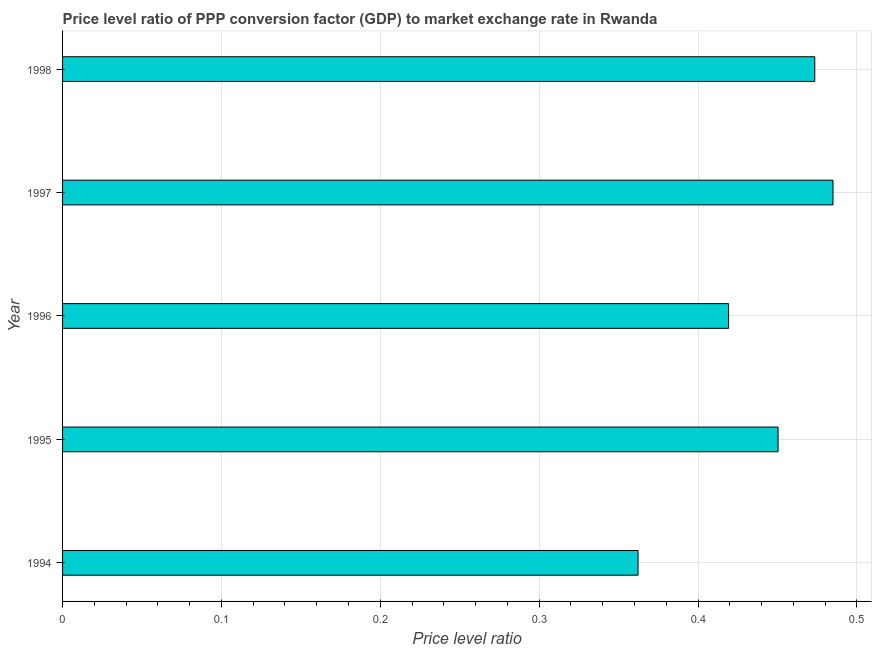What is the title of the graph?
Ensure brevity in your answer.  Price level ratio of PPP conversion factor (GDP) to market exchange rate in Rwanda. What is the label or title of the X-axis?
Provide a succinct answer. Price level ratio. What is the price level ratio in 1995?
Offer a terse response. 0.45. Across all years, what is the maximum price level ratio?
Offer a very short reply. 0.48. Across all years, what is the minimum price level ratio?
Provide a succinct answer. 0.36. In which year was the price level ratio maximum?
Your response must be concise. 1997. What is the sum of the price level ratio?
Offer a terse response. 2.19. What is the difference between the price level ratio in 1995 and 1998?
Your answer should be very brief. -0.02. What is the average price level ratio per year?
Make the answer very short. 0.44. What is the median price level ratio?
Make the answer very short. 0.45. What is the ratio of the price level ratio in 1995 to that in 1996?
Ensure brevity in your answer.  1.07. What is the difference between the highest and the second highest price level ratio?
Make the answer very short. 0.01. What is the difference between the highest and the lowest price level ratio?
Give a very brief answer. 0.12. Are all the bars in the graph horizontal?
Make the answer very short. Yes. How many years are there in the graph?
Offer a very short reply. 5. Are the values on the major ticks of X-axis written in scientific E-notation?
Offer a terse response. No. What is the Price level ratio in 1994?
Your response must be concise. 0.36. What is the Price level ratio of 1995?
Your answer should be very brief. 0.45. What is the Price level ratio of 1996?
Provide a short and direct response. 0.42. What is the Price level ratio of 1997?
Make the answer very short. 0.48. What is the Price level ratio in 1998?
Provide a succinct answer. 0.47. What is the difference between the Price level ratio in 1994 and 1995?
Offer a terse response. -0.09. What is the difference between the Price level ratio in 1994 and 1996?
Give a very brief answer. -0.06. What is the difference between the Price level ratio in 1994 and 1997?
Give a very brief answer. -0.12. What is the difference between the Price level ratio in 1994 and 1998?
Provide a short and direct response. -0.11. What is the difference between the Price level ratio in 1995 and 1996?
Your response must be concise. 0.03. What is the difference between the Price level ratio in 1995 and 1997?
Keep it short and to the point. -0.03. What is the difference between the Price level ratio in 1995 and 1998?
Offer a very short reply. -0.02. What is the difference between the Price level ratio in 1996 and 1997?
Offer a very short reply. -0.07. What is the difference between the Price level ratio in 1996 and 1998?
Provide a short and direct response. -0.05. What is the difference between the Price level ratio in 1997 and 1998?
Keep it short and to the point. 0.01. What is the ratio of the Price level ratio in 1994 to that in 1995?
Give a very brief answer. 0.8. What is the ratio of the Price level ratio in 1994 to that in 1996?
Your answer should be very brief. 0.86. What is the ratio of the Price level ratio in 1994 to that in 1997?
Your answer should be very brief. 0.75. What is the ratio of the Price level ratio in 1994 to that in 1998?
Offer a very short reply. 0.77. What is the ratio of the Price level ratio in 1995 to that in 1996?
Make the answer very short. 1.07. What is the ratio of the Price level ratio in 1995 to that in 1997?
Ensure brevity in your answer.  0.93. What is the ratio of the Price level ratio in 1995 to that in 1998?
Offer a terse response. 0.95. What is the ratio of the Price level ratio in 1996 to that in 1997?
Your answer should be very brief. 0.86. What is the ratio of the Price level ratio in 1996 to that in 1998?
Provide a short and direct response. 0.89. 